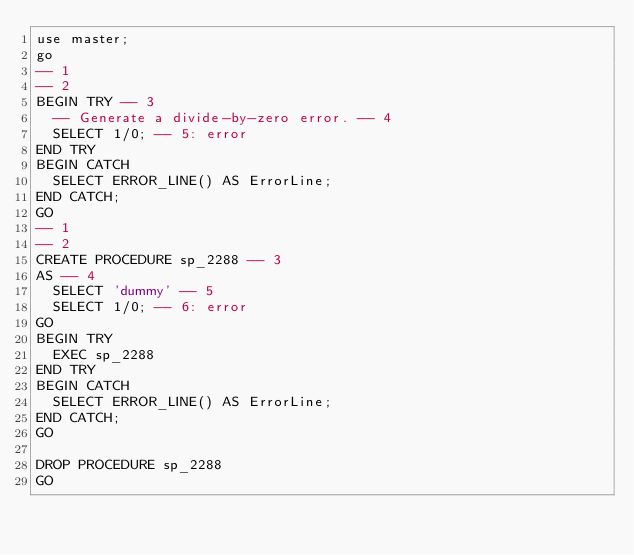<code> <loc_0><loc_0><loc_500><loc_500><_SQL_>use master;
go
-- 1
-- 2
BEGIN TRY -- 3
  -- Generate a divide-by-zero error. -- 4
  SELECT 1/0; -- 5: error
END TRY
BEGIN CATCH
  SELECT ERROR_LINE() AS ErrorLine;
END CATCH;
GO
-- 1
-- 2
CREATE PROCEDURE sp_2288 -- 3
AS -- 4
  SELECT 'dummy' -- 5
  SELECT 1/0; -- 6: error
GO
BEGIN TRY
  EXEC sp_2288
END TRY
BEGIN CATCH
  SELECT ERROR_LINE() AS ErrorLine;
END CATCH;
GO

DROP PROCEDURE sp_2288
GO
</code> 